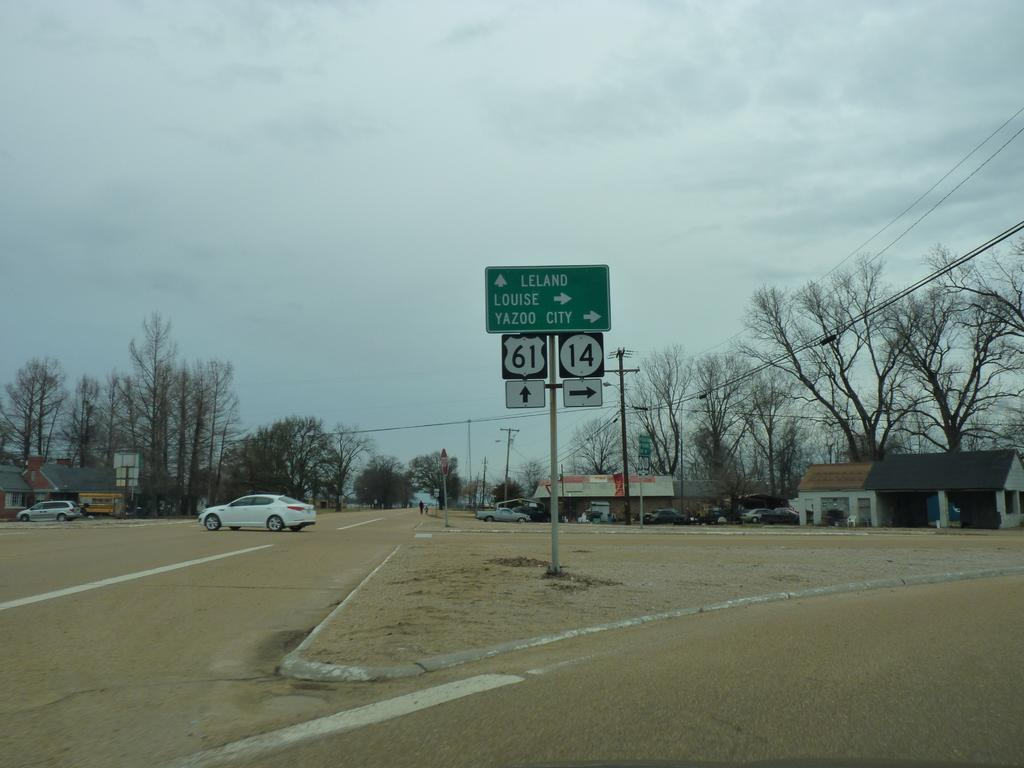What objects are present in the image? There are boards, vehicles, sheds, trees, poles, and the sky visible in the image. Can you describe the vehicles in the image? Vehicles are visible on the road in the image. What can be seen in the background of the image? In the background of the image, there are sheds, trees, poles, and the sky. What type of plastic is used to make the jelly visible in the image? There is no jelly or plastic present in the image. 